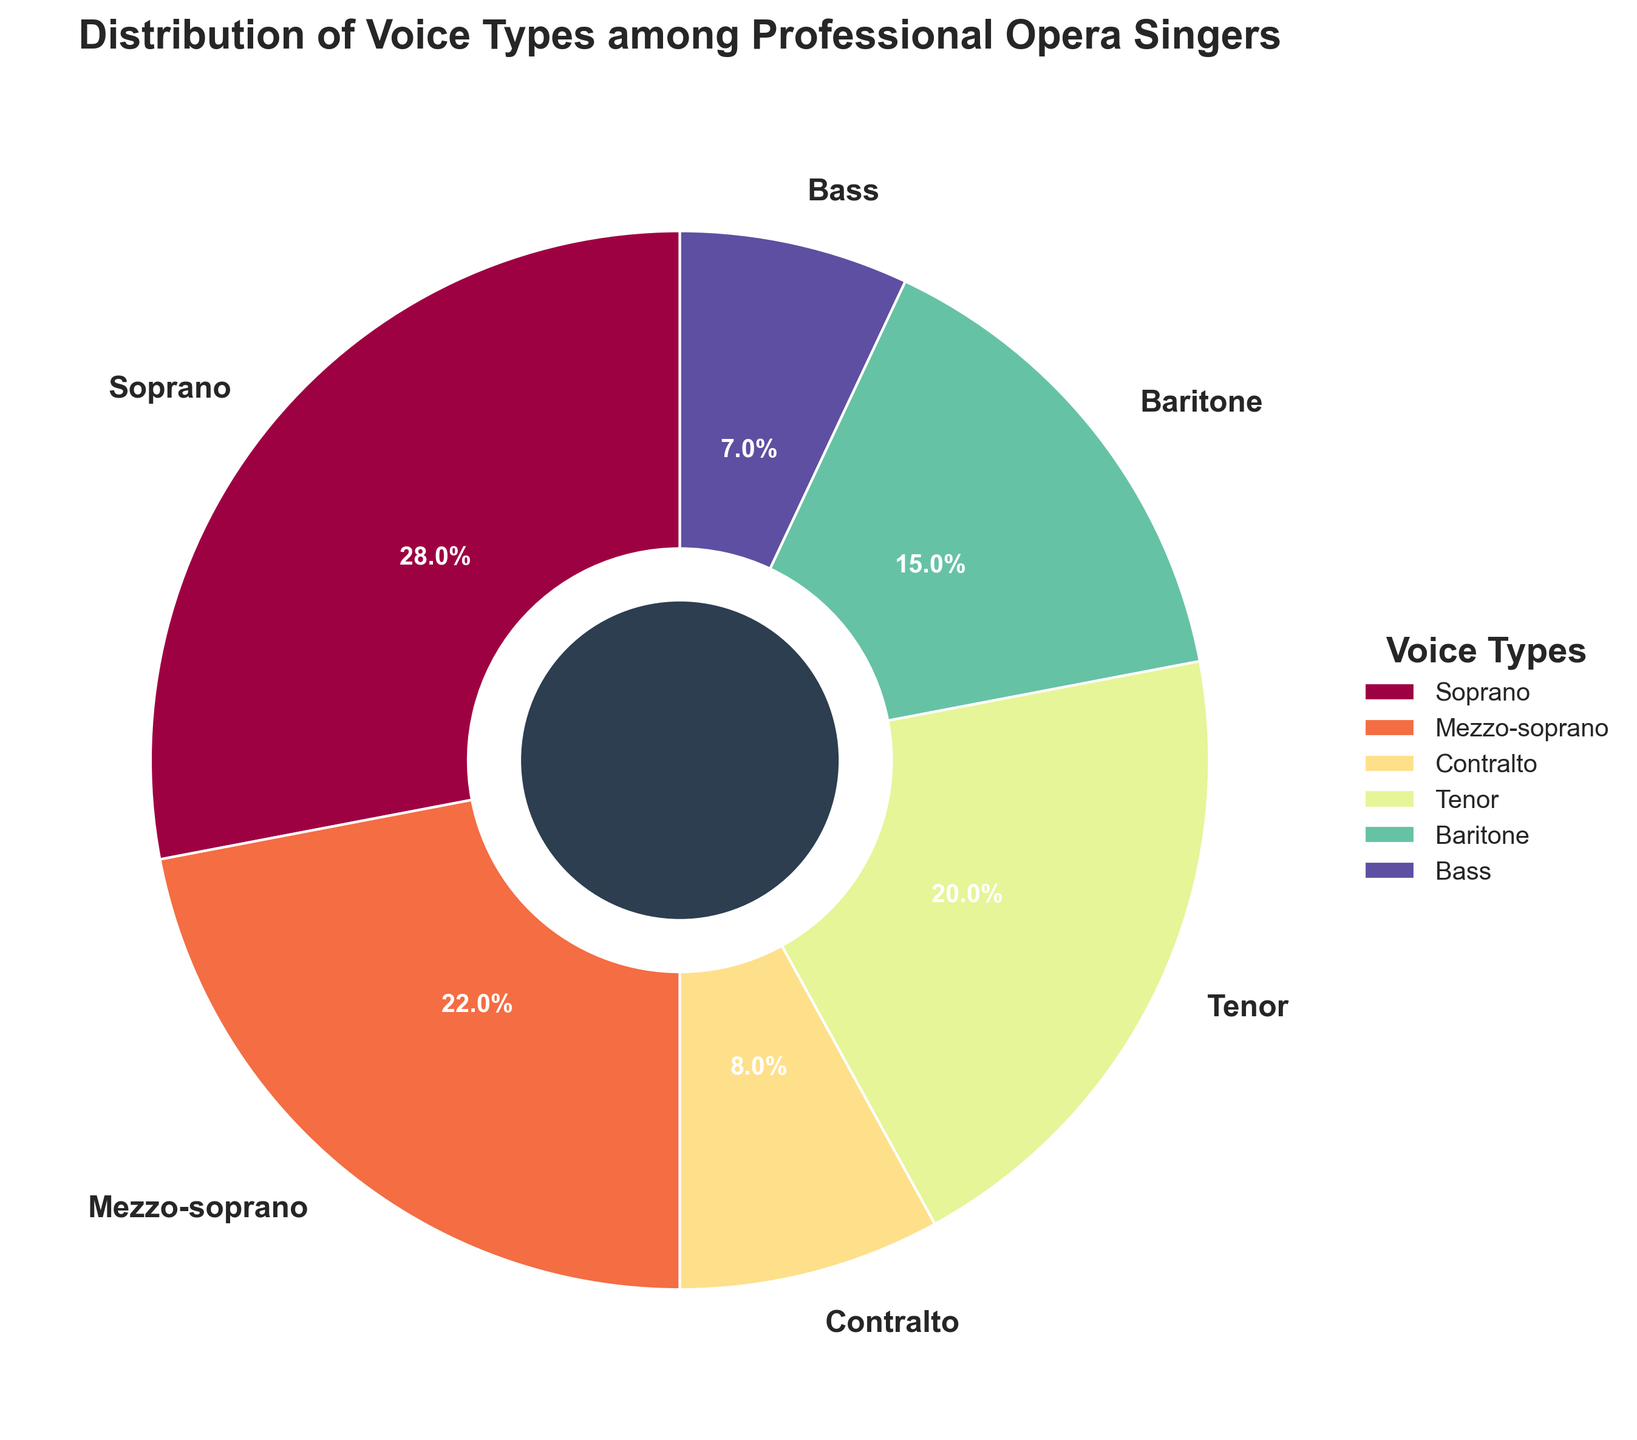What's the most common voice type among professional opera singers? The pie chart shows the distribution of different voice types. Soprano has the highest percentage slice.
Answer: Soprano Which voice types have nearly equal percentages? Tenor and Baritone have slices of 20% and 15%, respectively, making their percentages relatively close.
Answer: Tenor and Baritone Are there more soprano or bass singers, and by how much? The Soprano slice is 28%, whereas Bass is 7%. The difference is 28% - 7% = 21%.
Answer: Soprano by 21% What percentage of singers are either baritone or contralto? Add the percentage slices for Baritone and Contralto: 15% + 8% = 23%.
Answer: 23% What's the ratio of mezzo-sopranos to sopranos? The percentage for Mezzo-soprano is 22% and for Soprano is 28%. The ratio is 22:28, which simplifies to 11:14.
Answer: 11:14 Which types of singers account for more than 20% of the total? The slices for Soprano (28%) and Mezzo-soprano (22%) exceed 20%.
Answer: Soprano and Mezzo-soprano In terms of percentage, how do mezzo-soprano and baritone combined compare to tenor? Mezzo-soprano and Baritone together are 22% + 15% = 37%, while Tenor is 20%.
Answer: 37% vs 20% If there are 100 professional opera singers, how many would be tenors? Tenors represent 20% of the pie chart. 20% of 100 singers is 0.20 * 100 = 20.
Answer: 20 What's the difference in percentage between the most and least common voice types? The most common is Soprano at 28% and the least common is Bass at 7%. The difference is 28% - 7% = 21%.
Answer: 21% Assuming 100 singers total, how many more sopranos are there than contraltos? Soprano accounts for 28% and Contralto for 8%. For 100 singers, that’s 28 - 8 = 20 more Sopranos.
Answer: 20 